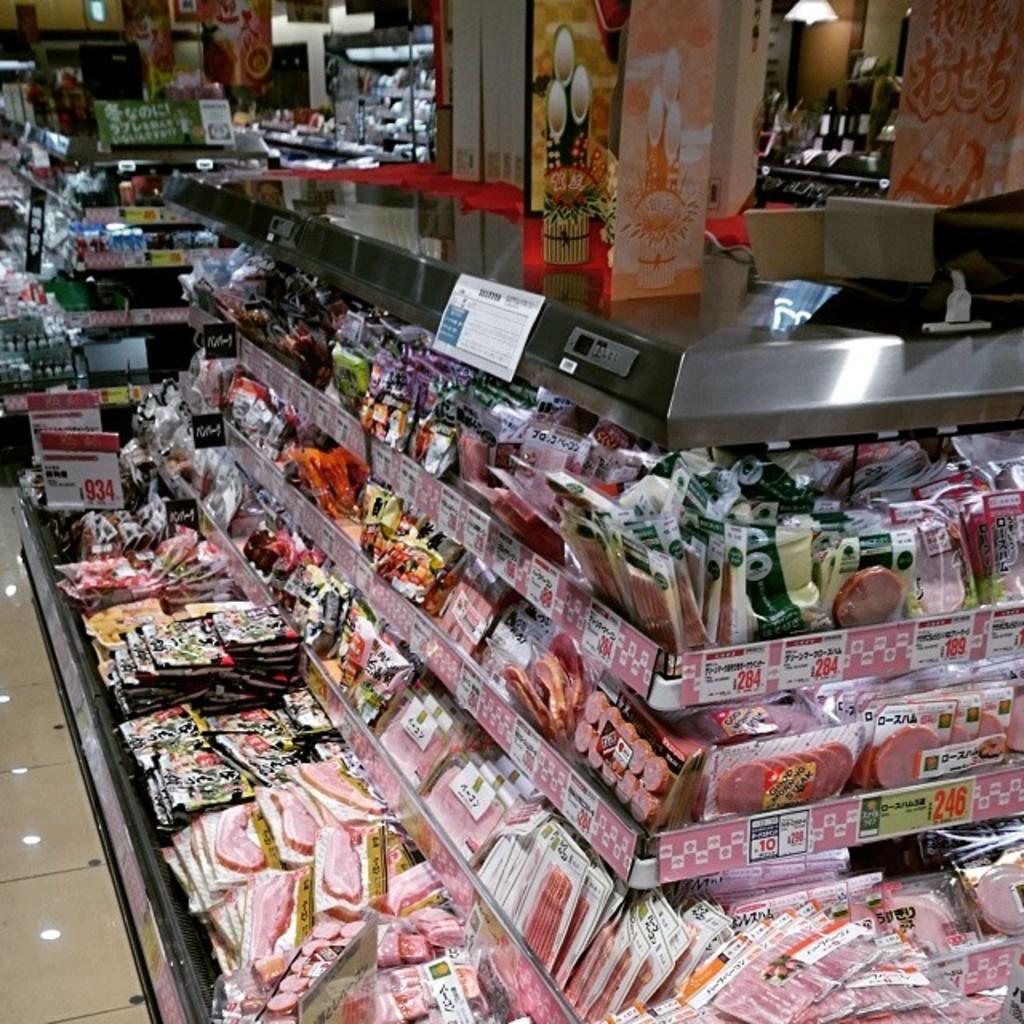Can you describe this image briefly? In this image I can see food packets. There are price boards, there are boxes and there are some objects. 